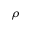Convert formula to latex. <formula><loc_0><loc_0><loc_500><loc_500>\rho</formula> 